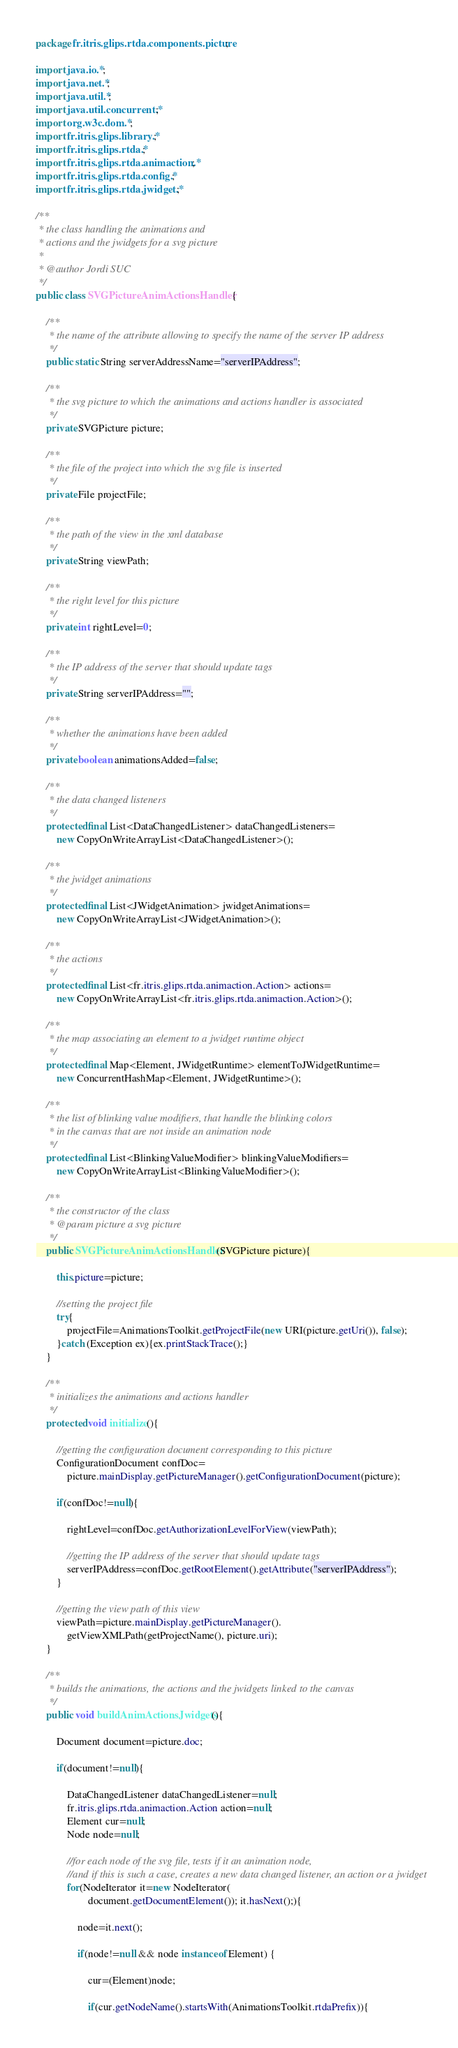Convert code to text. <code><loc_0><loc_0><loc_500><loc_500><_Java_>package fr.itris.glips.rtda.components.picture;

import java.io.*;
import java.net.*;
import java.util.*;
import java.util.concurrent.*;
import org.w3c.dom.*;
import fr.itris.glips.library.*;
import fr.itris.glips.rtda.*;
import fr.itris.glips.rtda.animaction.*;
import fr.itris.glips.rtda.config.*;
import fr.itris.glips.rtda.jwidget.*;

/**
 * the class handling the animations and 
 * actions and the jwidgets for a svg picture
 * 
 * @author Jordi SUC
 */
public class SVGPictureAnimActionsHandler {

	/**
	 * the name of the attribute allowing to specify the name of the server IP address
	 */
	public static String serverAddressName="serverIPAddress";
	
	/**
	 * the svg picture to which the animations and actions handler is associated
	 */
	private SVGPicture picture;
	
	/**
	 * the file of the project into which the svg file is inserted
	 */
	private File projectFile;

	/**
	 * the path of the view in the xml database
	 */
	private String viewPath;
	
	/**
	 * the right level for this picture
	 */
	private int rightLevel=0;
	
	/**
	 * the IP address of the server that should update tags
	 */
	private String serverIPAddress="";
	
	/**
	 * whether the animations have been added
	 */
	private boolean animationsAdded=false;
	
	/**
	 * the data changed listeners
	 */
	protected final List<DataChangedListener> dataChangedListeners=
		new CopyOnWriteArrayList<DataChangedListener>();
	
	/**
	 * the jwidget animations
	 */
	protected final List<JWidgetAnimation> jwidgetAnimations=
		new CopyOnWriteArrayList<JWidgetAnimation>();
	
	/**
	 * the actions
	 */
	protected final List<fr.itris.glips.rtda.animaction.Action> actions=
		new CopyOnWriteArrayList<fr.itris.glips.rtda.animaction.Action>();
	
	/**
	 * the map associating an element to a jwidget runtime object
	 */
	protected final Map<Element, JWidgetRuntime> elementToJWidgetRuntime=
		new ConcurrentHashMap<Element, JWidgetRuntime>();
	
	/**
	 * the list of blinking value modifiers, that handle the blinking colors
	 * in the canvas that are not inside an animation node
	 */
	protected final List<BlinkingValueModifier> blinkingValueModifiers=
		new CopyOnWriteArrayList<BlinkingValueModifier>();
	
	/**
	 * the constructor of the class
	 * @param picture a svg picture
	 */
	public SVGPictureAnimActionsHandler(SVGPicture picture){
		
		this.picture=picture;
		
		//setting the project file
		try{
			projectFile=AnimationsToolkit.getProjectFile(new URI(picture.getUri()), false);
		}catch (Exception ex){ex.printStackTrace();}
	}
	
	/**
	 * initializes the animations and actions handler
	 */
	protected void initialize(){
		
		//getting the configuration document corresponding to this picture
		ConfigurationDocument confDoc=
			picture.mainDisplay.getPictureManager().getConfigurationDocument(picture);
		
		if(confDoc!=null){
			
			rightLevel=confDoc.getAuthorizationLevelForView(viewPath);
			
			//getting the IP address of the server that should update tags
			serverIPAddress=confDoc.getRootElement().getAttribute("serverIPAddress");
		}
		
		//getting the view path of this view
		viewPath=picture.mainDisplay.getPictureManager().
			getViewXMLPath(getProjectName(), picture.uri);
	}
	
	/**
	 * builds the animations, the actions and the jwidgets linked to the canvas
	 */
	public void buildAnimActionsJwidgets(){

		Document document=picture.doc;

		if(document!=null){
			
			DataChangedListener dataChangedListener=null;
			fr.itris.glips.rtda.animaction.Action action=null;
			Element cur=null;
			Node node=null;

			//for each node of the svg file, tests if it an animation node, 
			//and if this is such a case, creates a new data changed listener, an action or a jwidget
			for(NodeIterator it=new NodeIterator(
					document.getDocumentElement()); it.hasNext();){
				
				node=it.next();
				
				if(node!=null && node instanceof Element) {
					
					cur=(Element)node;
					
					if(cur.getNodeName().startsWith(AnimationsToolkit.rtdaPrefix)){
</code> 